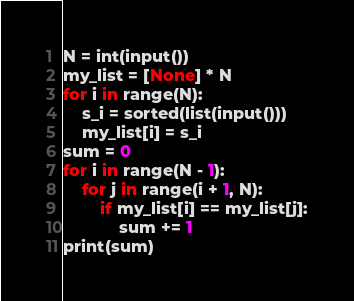<code> <loc_0><loc_0><loc_500><loc_500><_Python_>N = int(input())
my_list = [None] * N
for i in range(N):
    s_i = sorted(list(input()))
    my_list[i] = s_i
sum = 0
for i in range(N - 1):
    for j in range(i + 1, N):
        if my_list[i] == my_list[j]:
            sum += 1
print(sum)
</code> 